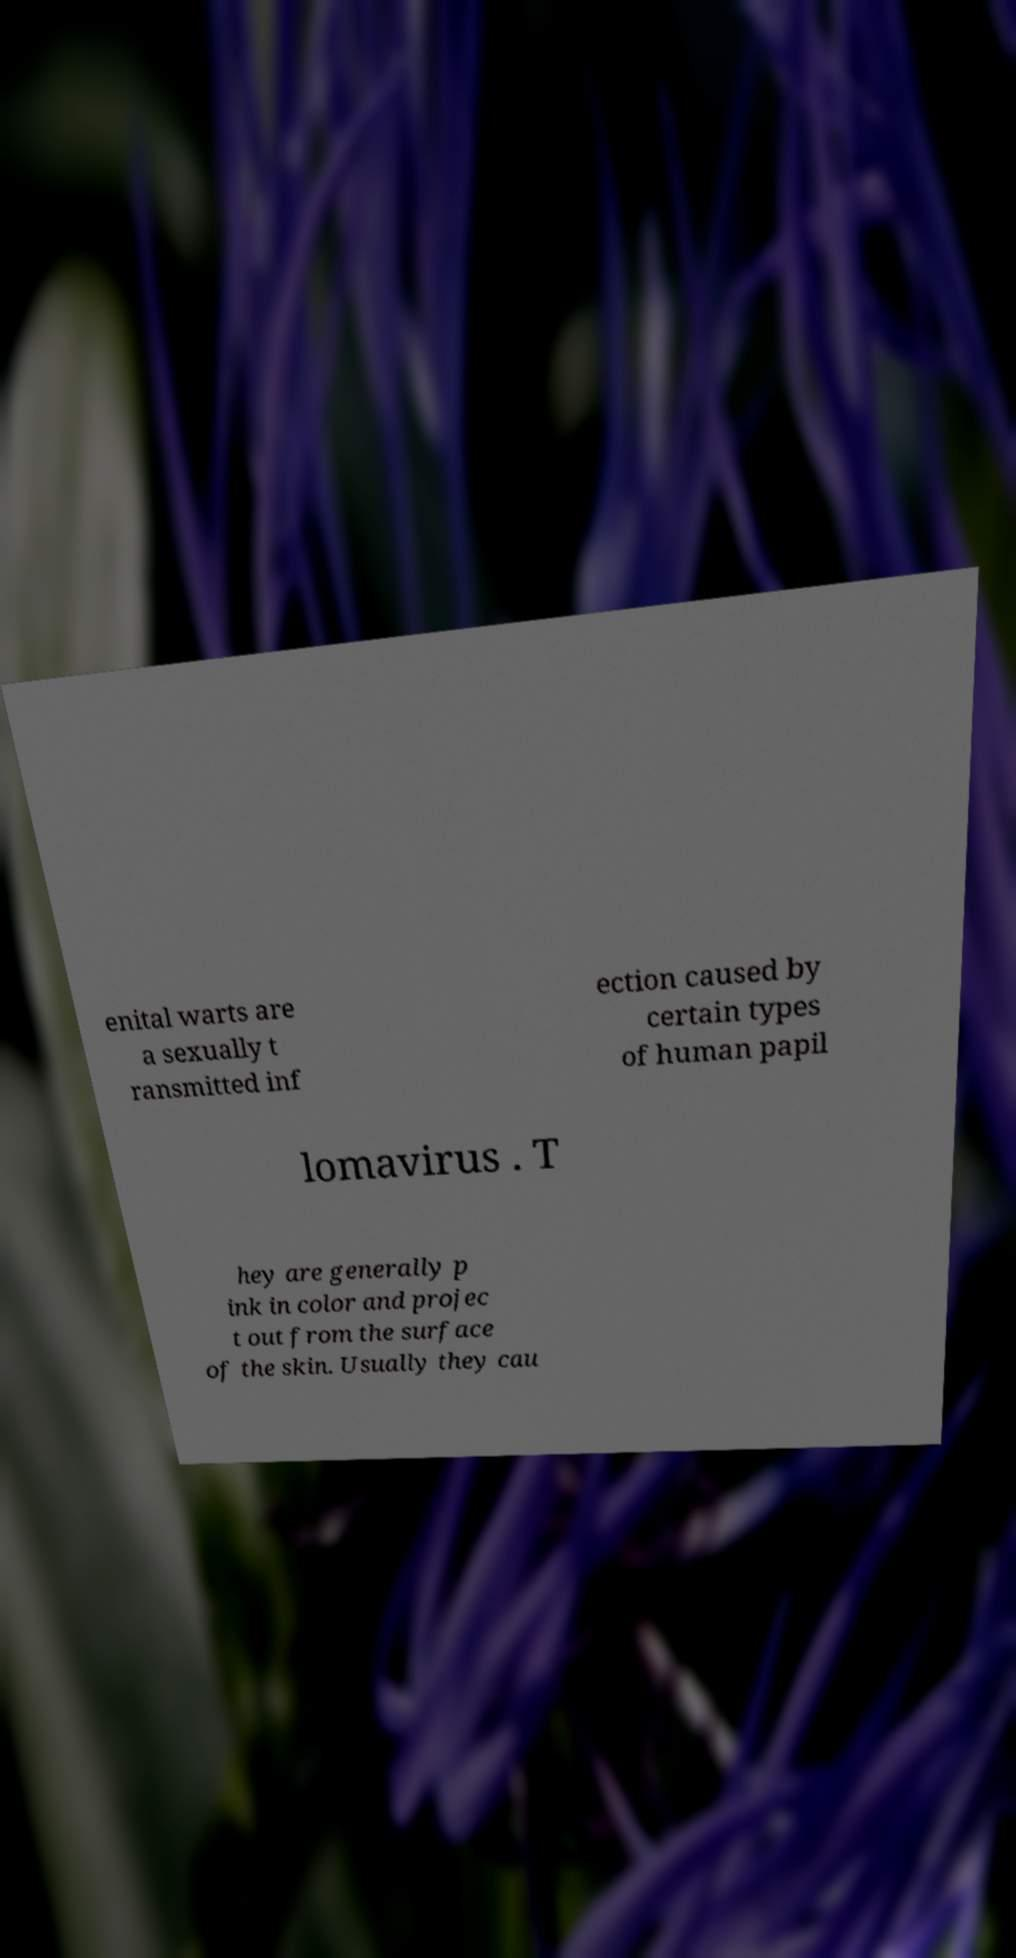Can you accurately transcribe the text from the provided image for me? enital warts are a sexually t ransmitted inf ection caused by certain types of human papil lomavirus . T hey are generally p ink in color and projec t out from the surface of the skin. Usually they cau 